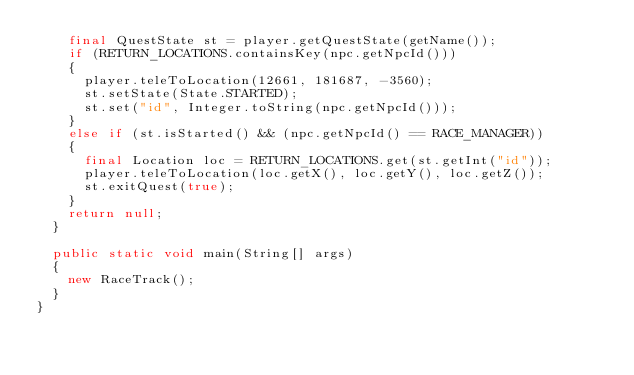<code> <loc_0><loc_0><loc_500><loc_500><_Java_>		final QuestState st = player.getQuestState(getName());
		if (RETURN_LOCATIONS.containsKey(npc.getNpcId()))
		{
			player.teleToLocation(12661, 181687, -3560);
			st.setState(State.STARTED);
			st.set("id", Integer.toString(npc.getNpcId()));
		}
		else if (st.isStarted() && (npc.getNpcId() == RACE_MANAGER))
		{
			final Location loc = RETURN_LOCATIONS.get(st.getInt("id"));
			player.teleToLocation(loc.getX(), loc.getY(), loc.getZ());
			st.exitQuest(true);
		}
		return null;
	}
	
	public static void main(String[] args)
	{
		new RaceTrack();
	}
}</code> 